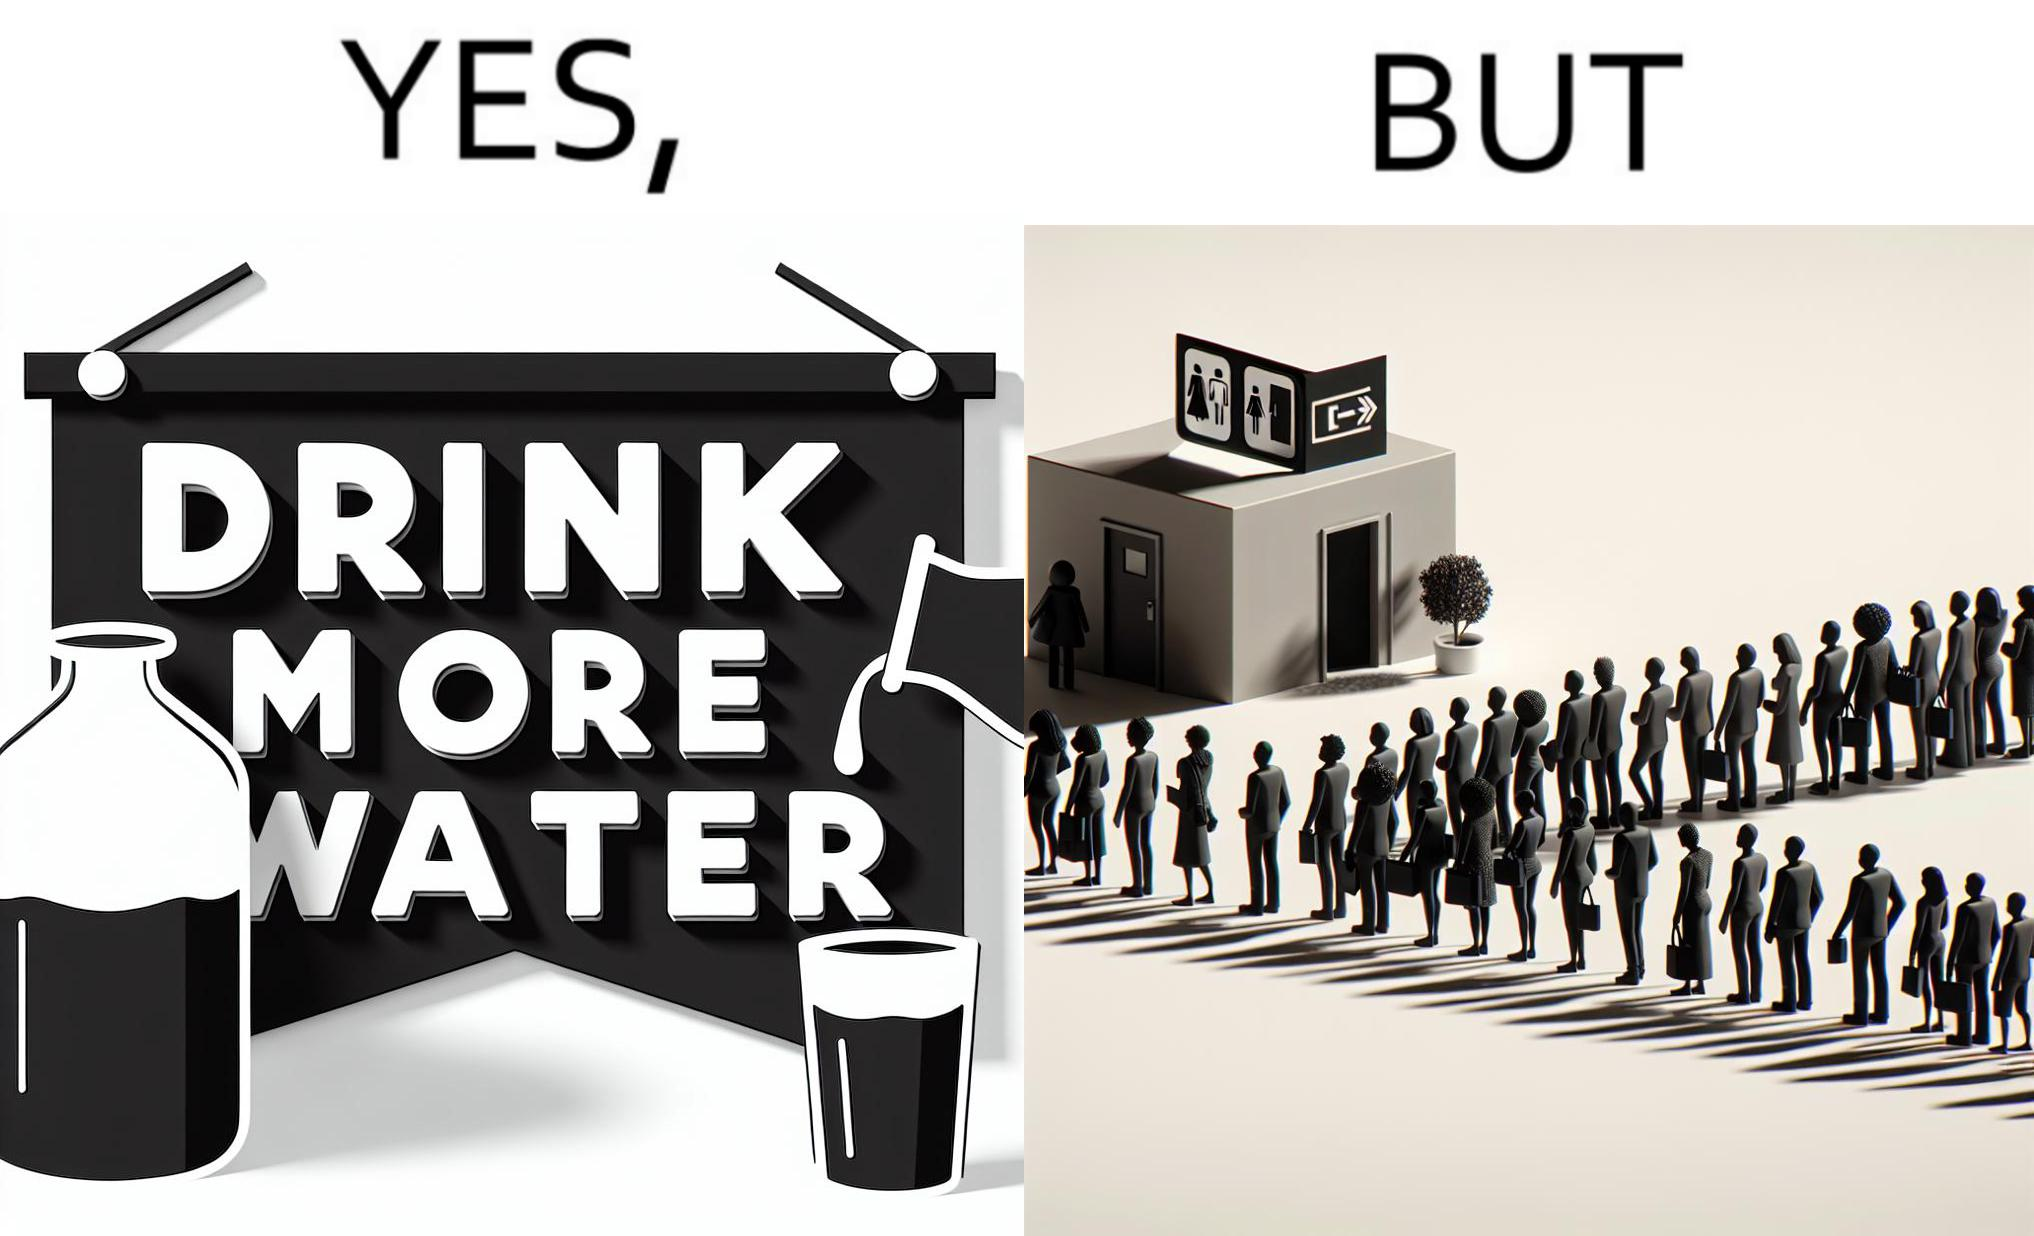Why is this image considered satirical? The image is ironical, as the message "Drink more water" is meant to improve health, but in turn, it would lead to longer queues in front of public toilets, leading to people holding urine for longer periods, in turn leading to deterioration in health. 